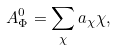<formula> <loc_0><loc_0><loc_500><loc_500>A _ { \Phi } ^ { 0 } = \sum _ { \chi } a _ { \chi } \chi ,</formula> 